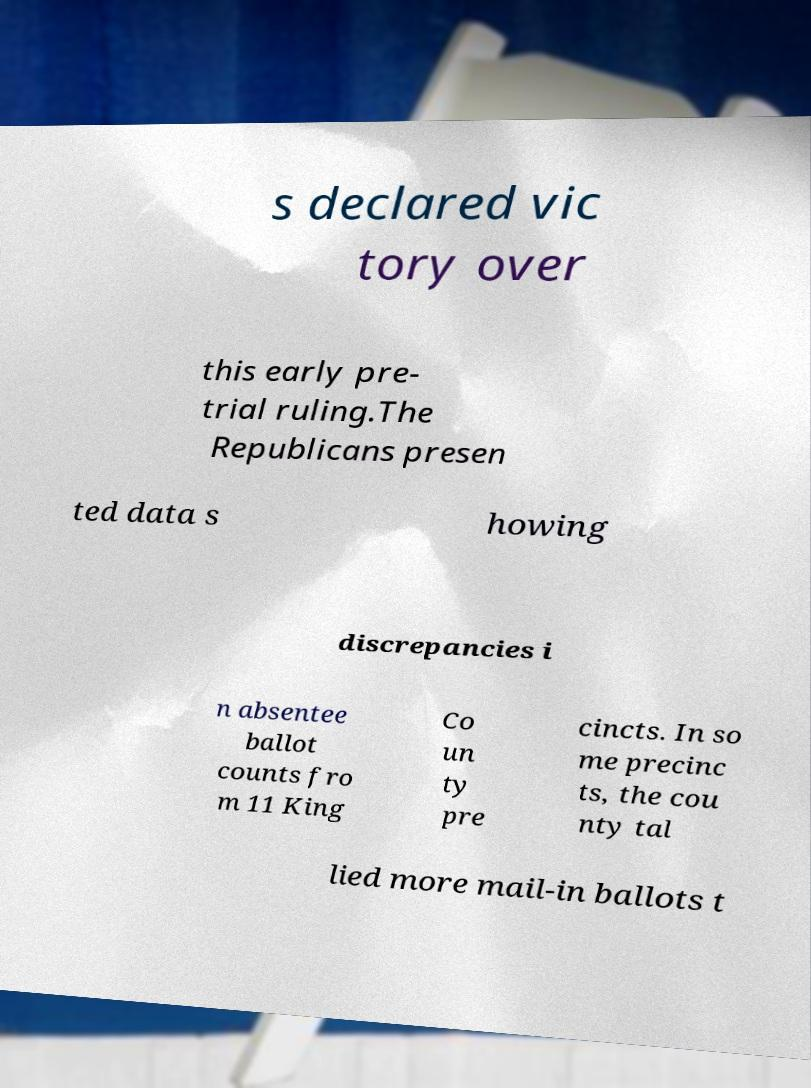Please read and relay the text visible in this image. What does it say? s declared vic tory over this early pre- trial ruling.The Republicans presen ted data s howing discrepancies i n absentee ballot counts fro m 11 King Co un ty pre cincts. In so me precinc ts, the cou nty tal lied more mail-in ballots t 